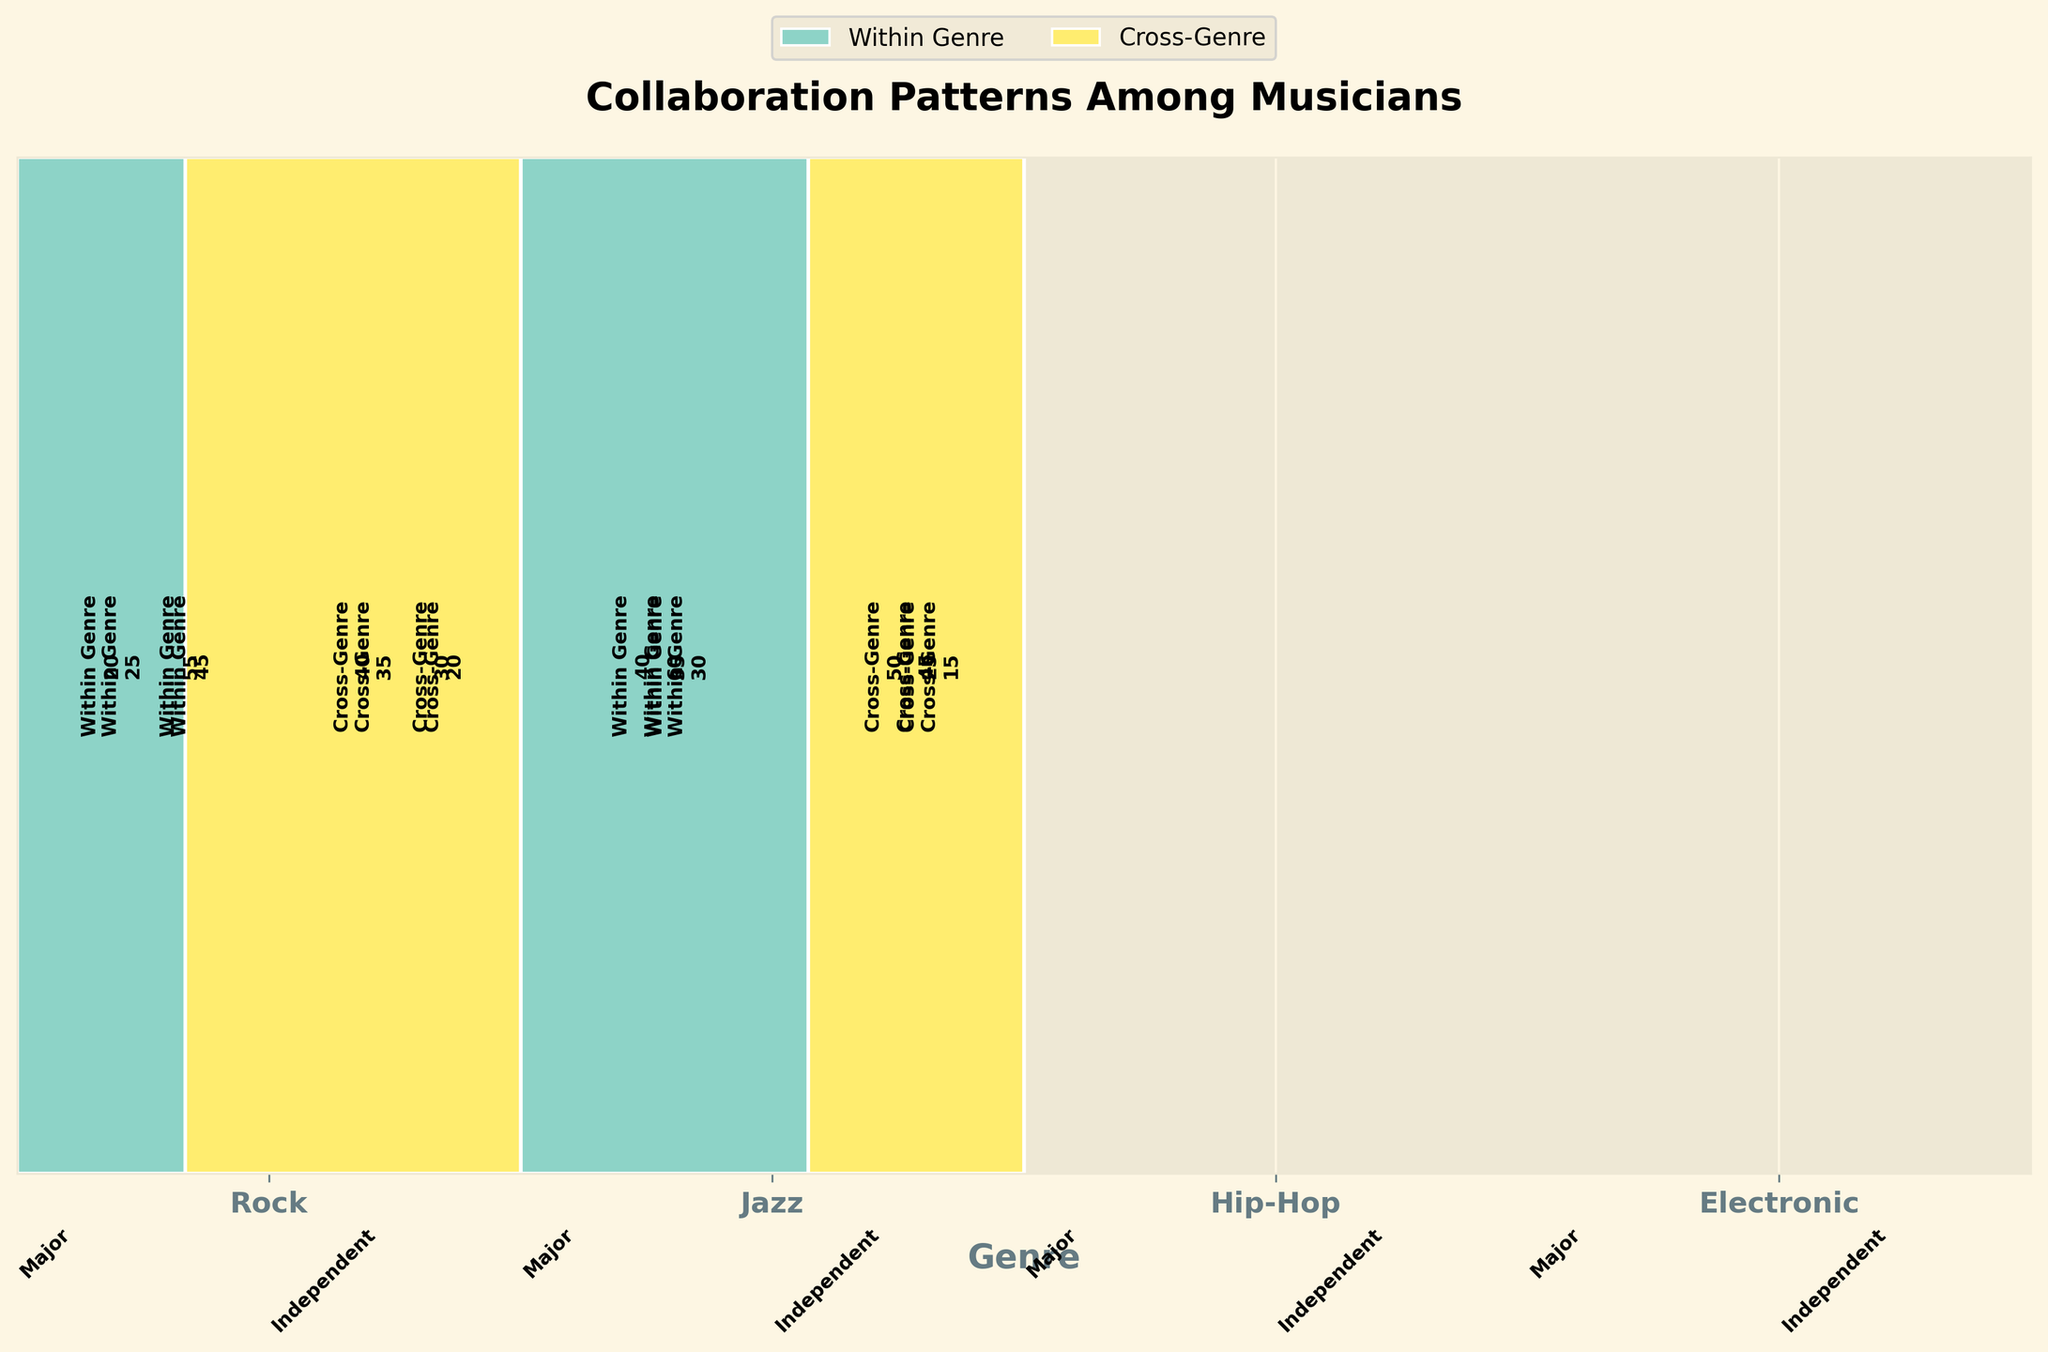What's the title of the plot? The plot's title is usually placed at the top of the chart. By looking at this location, we see the title "Collaboration Patterns Among Musicians."
Answer: Collaboration Patterns Among Musicians What are the genres represented in the plot? The genres should be listed on the x-axis as labels. Observing the x-axis labels, we see the genres "Rock," "Jazz," "Hip-Hop," and "Electronic."
Answer: Rock, Jazz, Hip-Hop, Electronic Which collaboration type within the Hip-Hop genre and independent label has the lowest count? Locate the Hip-Hop genre and independent label section, then compare the heights of the segments for "Within Genre" and "Cross-Genre." The "Cross-Genre" segment is lower.
Answer: Cross-Genre How many total collaborations are there within the Jazz genre for both major and independent labels combined? Locate the Jazz genre sections for both major and independent labels, sum the counts of all four collaboration types: 25 ("Within Genre") + 35 ("Cross-Genre") + 40 ("Within Genre") + 50 ("Cross-Genre") = 150.
Answer: 150 Which genre has the highest count of "Within Genre" collaborations for an independent label? Focus on the independent sections for each genre and compare the heights of the "Within Genre" segments. Electronic stands out as having the highest count.
Answer: Electronic Which label size has more "Cross-Genre" collaborations in the Hip-Hop genre? Compare the heights of the "Cross-Genre" segments within the Hip-Hop genre for both major and independent labels. The major label has a higher count.
Answer: Major Between major and independent labels, which one has a higher count of total collaborations within the Electronic genre? Sum the counts of all four collaboration types within the Electronic genre for both major and independent labels: Major (20 "Within Genre" + 40 "Cross-Genre" = 60), Independent (60 "Within Genre" + 45 "Cross-Genre" = 105). Independent has a higher total count.
Answer: Independent How does the number of "Cross-Genre" collaborations in Jazz for independent labels compare to the number in Rock for independent labels? Find the counts of "Cross-Genre" collaborations for independent labels in both genres: Jazz (50), Rock (15). Jazz has more than Rock.
Answer: Jazz has more Which genre has the smallest representation in major labels when considering both collaboration types? Sum the "Within Genre" and "Cross-Genre" counts for major labels in each genre: Rock (45+20=65), Jazz (25+35=60), Hip-Hop (55+30=85), Electronic (20+40=60). Both Jazz and Electronic are the smallest, with 60 each.
Answer: Jazz and Electronic 